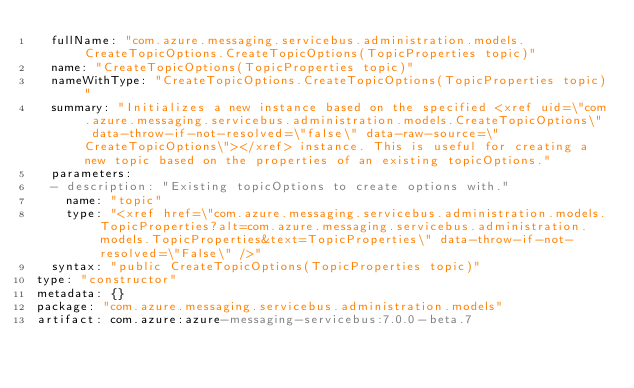Convert code to text. <code><loc_0><loc_0><loc_500><loc_500><_YAML_>  fullName: "com.azure.messaging.servicebus.administration.models.CreateTopicOptions.CreateTopicOptions(TopicProperties topic)"
  name: "CreateTopicOptions(TopicProperties topic)"
  nameWithType: "CreateTopicOptions.CreateTopicOptions(TopicProperties topic)"
  summary: "Initializes a new instance based on the specified <xref uid=\"com.azure.messaging.servicebus.administration.models.CreateTopicOptions\" data-throw-if-not-resolved=\"false\" data-raw-source=\"CreateTopicOptions\"></xref> instance. This is useful for creating a new topic based on the properties of an existing topicOptions."
  parameters:
  - description: "Existing topicOptions to create options with."
    name: "topic"
    type: "<xref href=\"com.azure.messaging.servicebus.administration.models.TopicProperties?alt=com.azure.messaging.servicebus.administration.models.TopicProperties&text=TopicProperties\" data-throw-if-not-resolved=\"False\" />"
  syntax: "public CreateTopicOptions(TopicProperties topic)"
type: "constructor"
metadata: {}
package: "com.azure.messaging.servicebus.administration.models"
artifact: com.azure:azure-messaging-servicebus:7.0.0-beta.7
</code> 